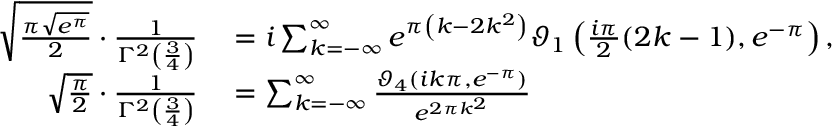Convert formula to latex. <formula><loc_0><loc_0><loc_500><loc_500>\begin{array} { r l } { { \sqrt { \frac { \pi { \sqrt { e ^ { \pi } } } } { 2 } } } \cdot { \frac { 1 } { \Gamma ^ { 2 } \left ( { \frac { 3 } { 4 } } \right ) } } } & = i \sum _ { k = - \infty } ^ { \infty } e ^ { \pi \left ( k - 2 k ^ { 2 } \right ) } \vartheta _ { 1 } \left ( { \frac { i \pi } { 2 } } ( 2 k - 1 ) , e ^ { - \pi } \right ) , } \\ { { \sqrt { \frac { \pi } { 2 } } } \cdot { \frac { 1 } { \Gamma ^ { 2 } \left ( { \frac { 3 } { 4 } } \right ) } } } & = \sum _ { k = - \infty } ^ { \infty } { \frac { \vartheta _ { 4 } \left ( i k \pi , e ^ { - \pi } \right ) } { e ^ { 2 \pi k ^ { 2 } } } } } \end{array}</formula> 